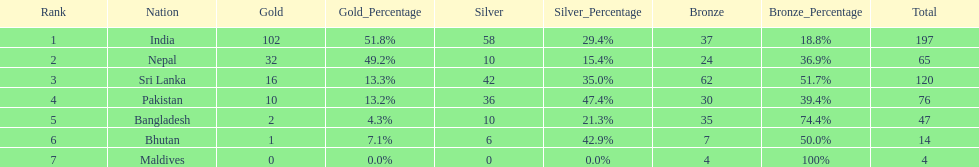What is the difference between the nation with the most medals and the nation with the least amount of medals? 193. 